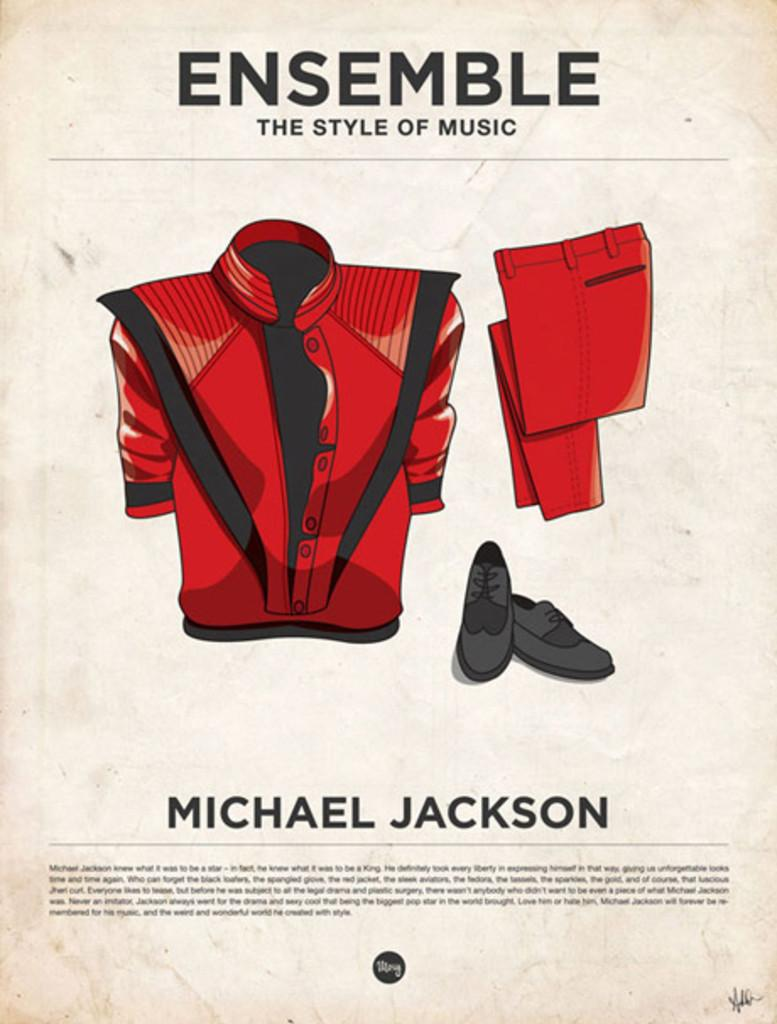<image>
Offer a succinct explanation of the picture presented. a Michael Jackson sheet with other items on it 